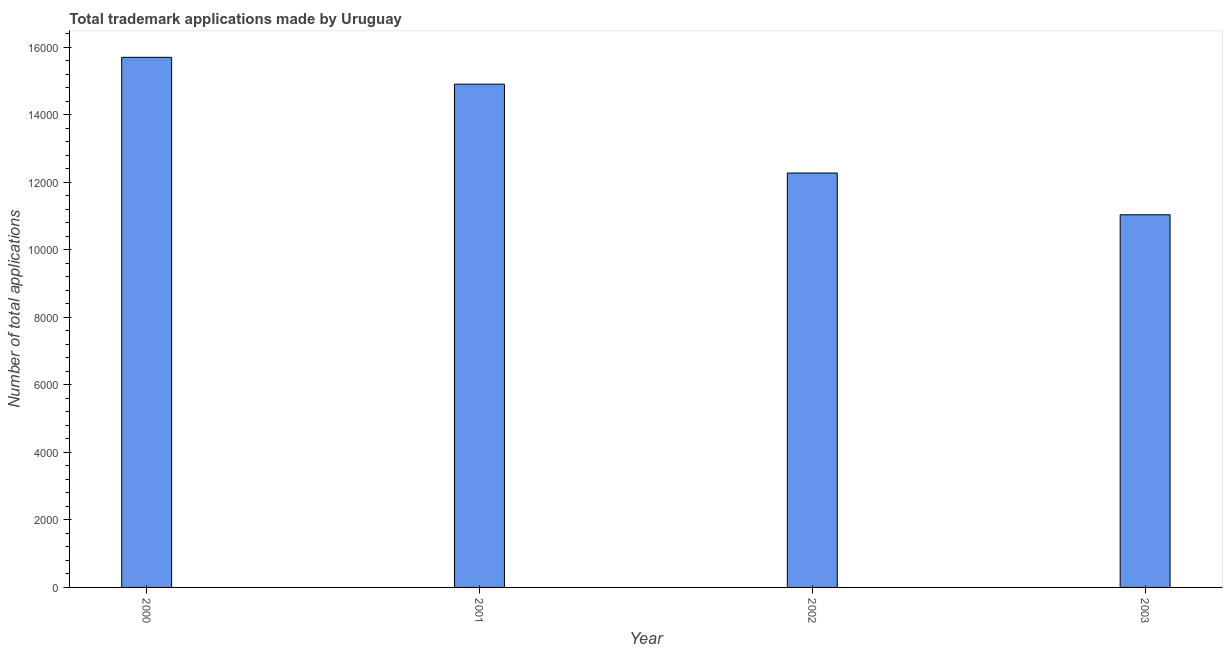What is the title of the graph?
Make the answer very short. Total trademark applications made by Uruguay. What is the label or title of the X-axis?
Offer a terse response. Year. What is the label or title of the Y-axis?
Provide a short and direct response. Number of total applications. What is the number of trademark applications in 2000?
Offer a terse response. 1.57e+04. Across all years, what is the maximum number of trademark applications?
Make the answer very short. 1.57e+04. Across all years, what is the minimum number of trademark applications?
Your answer should be compact. 1.10e+04. In which year was the number of trademark applications minimum?
Make the answer very short. 2003. What is the sum of the number of trademark applications?
Your response must be concise. 5.39e+04. What is the difference between the number of trademark applications in 2000 and 2003?
Keep it short and to the point. 4663. What is the average number of trademark applications per year?
Your answer should be compact. 1.35e+04. What is the median number of trademark applications?
Keep it short and to the point. 1.36e+04. Do a majority of the years between 2002 and 2000 (inclusive) have number of trademark applications greater than 6800 ?
Your response must be concise. Yes. What is the ratio of the number of trademark applications in 2000 to that in 2001?
Provide a short and direct response. 1.05. Is the number of trademark applications in 2002 less than that in 2003?
Make the answer very short. No. What is the difference between the highest and the second highest number of trademark applications?
Your answer should be very brief. 794. Is the sum of the number of trademark applications in 2001 and 2003 greater than the maximum number of trademark applications across all years?
Your response must be concise. Yes. What is the difference between the highest and the lowest number of trademark applications?
Your answer should be very brief. 4663. In how many years, is the number of trademark applications greater than the average number of trademark applications taken over all years?
Offer a terse response. 2. How many bars are there?
Your response must be concise. 4. What is the difference between two consecutive major ticks on the Y-axis?
Offer a terse response. 2000. Are the values on the major ticks of Y-axis written in scientific E-notation?
Ensure brevity in your answer.  No. What is the Number of total applications in 2000?
Make the answer very short. 1.57e+04. What is the Number of total applications in 2001?
Keep it short and to the point. 1.49e+04. What is the Number of total applications of 2002?
Your response must be concise. 1.23e+04. What is the Number of total applications in 2003?
Give a very brief answer. 1.10e+04. What is the difference between the Number of total applications in 2000 and 2001?
Offer a very short reply. 794. What is the difference between the Number of total applications in 2000 and 2002?
Your answer should be very brief. 3426. What is the difference between the Number of total applications in 2000 and 2003?
Provide a short and direct response. 4663. What is the difference between the Number of total applications in 2001 and 2002?
Your answer should be compact. 2632. What is the difference between the Number of total applications in 2001 and 2003?
Provide a succinct answer. 3869. What is the difference between the Number of total applications in 2002 and 2003?
Ensure brevity in your answer.  1237. What is the ratio of the Number of total applications in 2000 to that in 2001?
Your answer should be very brief. 1.05. What is the ratio of the Number of total applications in 2000 to that in 2002?
Offer a terse response. 1.28. What is the ratio of the Number of total applications in 2000 to that in 2003?
Offer a terse response. 1.42. What is the ratio of the Number of total applications in 2001 to that in 2002?
Your answer should be very brief. 1.21. What is the ratio of the Number of total applications in 2001 to that in 2003?
Keep it short and to the point. 1.35. What is the ratio of the Number of total applications in 2002 to that in 2003?
Offer a very short reply. 1.11. 